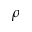<formula> <loc_0><loc_0><loc_500><loc_500>\rho</formula> 